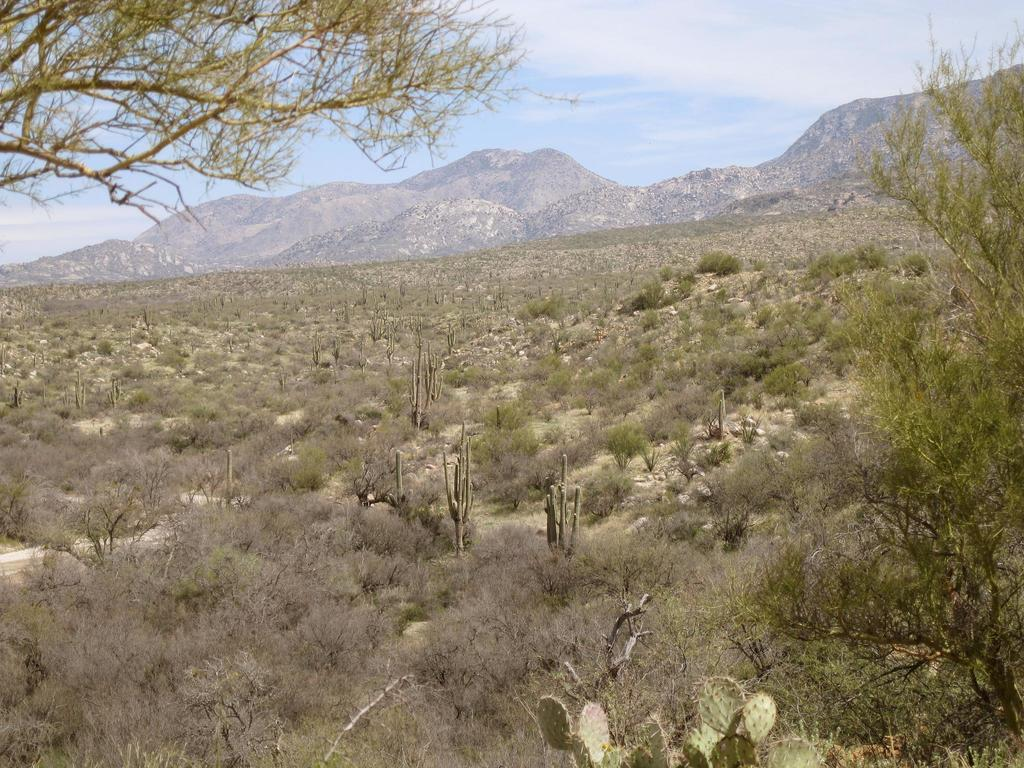What type of vegetation can be seen in the image? There are trees and plants in the image. What other natural elements are present in the image? There are rocks in the image. What type of landscape feature is visible in the distance? There are mountains visible in the image. What type of substance is being used to condition the beetle's shell in the image? There is no beetle or conditioning substance present in the image. 